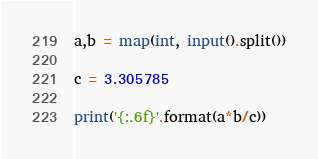Convert code to text. <code><loc_0><loc_0><loc_500><loc_500><_Python_>a,b = map(int, input().split())

c = 3.305785

print('{:.6f}'.format(a*b/c))
</code> 